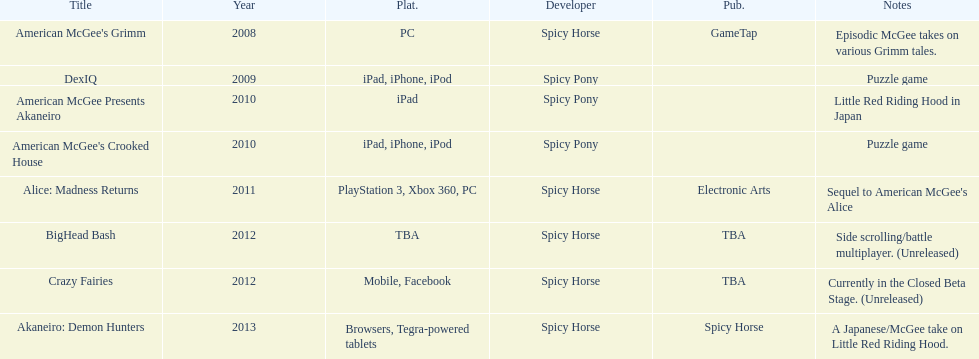Which title is for ipad but not for iphone or ipod? American McGee Presents Akaneiro. 